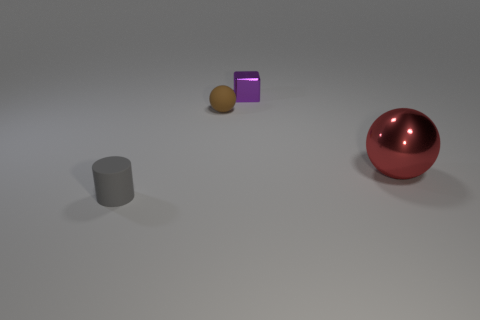What is the material of the object that is to the right of the small gray matte object and in front of the brown ball?
Offer a terse response. Metal. What is the shape of the big red metallic thing?
Ensure brevity in your answer.  Sphere. How many other things are the same material as the large red thing?
Ensure brevity in your answer.  1. Is the brown matte thing the same size as the red metal sphere?
Your response must be concise. No. There is a tiny thing that is in front of the brown rubber sphere; what is its shape?
Your answer should be compact. Cylinder. What color is the tiny matte thing in front of the rubber object that is behind the tiny gray matte cylinder?
Provide a short and direct response. Gray. There is a metallic thing in front of the brown object; is its shape the same as the small matte thing that is behind the small gray rubber cylinder?
Provide a succinct answer. Yes. What shape is the purple metallic object that is the same size as the rubber sphere?
Provide a short and direct response. Cube. There is a sphere that is made of the same material as the cylinder; what color is it?
Your response must be concise. Brown. Does the gray thing have the same shape as the matte object that is behind the big red thing?
Keep it short and to the point. No. 